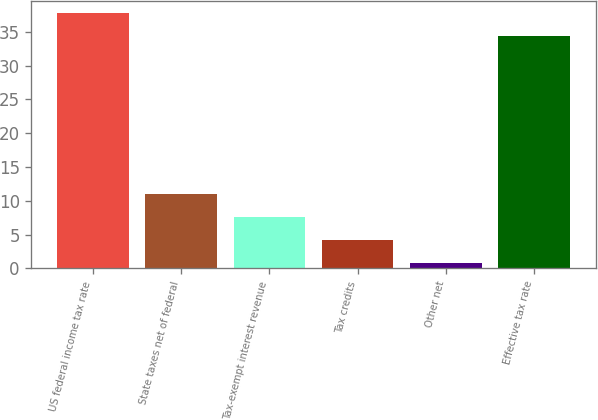Convert chart. <chart><loc_0><loc_0><loc_500><loc_500><bar_chart><fcel>US federal income tax rate<fcel>State taxes net of federal<fcel>Tax-exempt interest revenue<fcel>Tax credits<fcel>Other net<fcel>Effective tax rate<nl><fcel>37.72<fcel>11.06<fcel>7.64<fcel>4.22<fcel>0.8<fcel>34.3<nl></chart> 